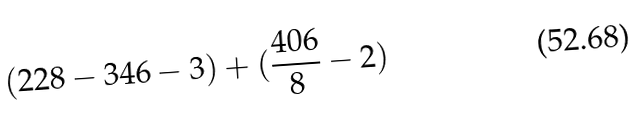<formula> <loc_0><loc_0><loc_500><loc_500>( 2 2 8 - 3 4 6 - 3 ) + ( \frac { 4 0 6 } { 8 } - 2 )</formula> 